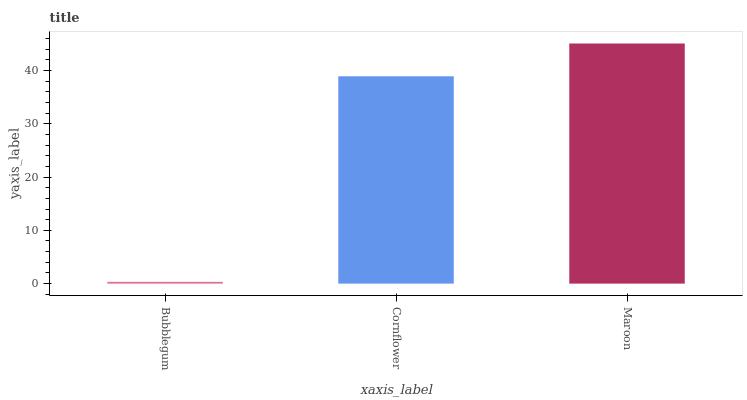Is Bubblegum the minimum?
Answer yes or no. Yes. Is Maroon the maximum?
Answer yes or no. Yes. Is Cornflower the minimum?
Answer yes or no. No. Is Cornflower the maximum?
Answer yes or no. No. Is Cornflower greater than Bubblegum?
Answer yes or no. Yes. Is Bubblegum less than Cornflower?
Answer yes or no. Yes. Is Bubblegum greater than Cornflower?
Answer yes or no. No. Is Cornflower less than Bubblegum?
Answer yes or no. No. Is Cornflower the high median?
Answer yes or no. Yes. Is Cornflower the low median?
Answer yes or no. Yes. Is Bubblegum the high median?
Answer yes or no. No. Is Maroon the low median?
Answer yes or no. No. 